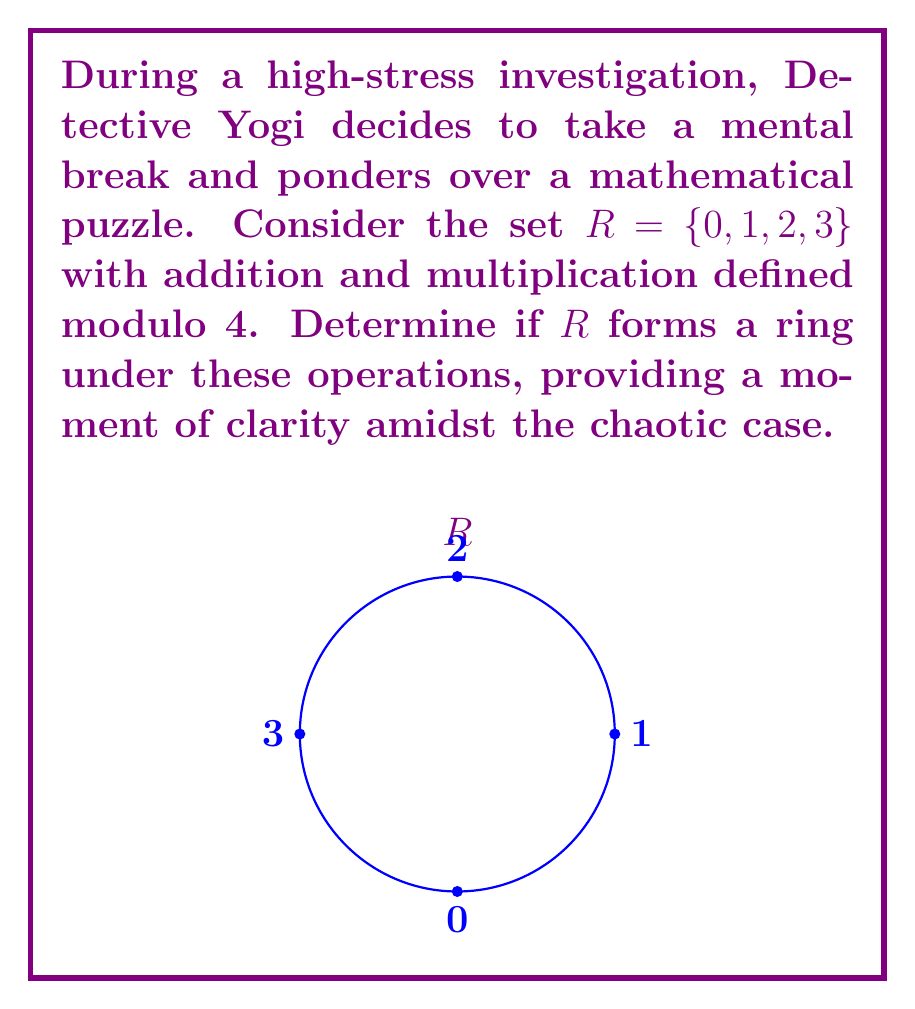Could you help me with this problem? To determine if $R$ forms a ring, we need to check if it satisfies the ring axioms:

1. $(R, +)$ is an abelian group:
   a) Closure: For all $a,b \in R$, $a + b \in R$ (mod 4)
   b) Associativity: $(a + b) + c = a + (b + c)$ for all $a,b,c \in R$
   c) Commutativity: $a + b = b + a$ for all $a,b \in R$
   d) Identity: $0$ is the additive identity
   e) Inverse: Each element has an additive inverse

2. $(R, \cdot)$ is a monoid:
   a) Closure: For all $a,b \in R$, $a \cdot b \in R$ (mod 4)
   b) Associativity: $(a \cdot b) \cdot c = a \cdot (b \cdot c)$ for all $a,b,c \in R$
   c) Identity: $1$ is the multiplicative identity

3. Distributive laws:
   a) $a \cdot (b + c) = (a \cdot b) + (a \cdot c)$ for all $a,b,c \in R$
   b) $(b + c) \cdot a = (b \cdot a) + (c \cdot a)$ for all $a,b,c \in R$

Let's verify each condition:

1. $(R, +)$ is an abelian group:
   a) Closure: $0+0=0$, $0+1=1$, $0+2=2$, $0+3=3$, $1+1=2$, $1+2=3$, $1+3=0$, $2+2=0$, $2+3=1$, $3+3=2$ (all in $R$)
   b) Associativity: Holds for modular addition
   c) Commutativity: Holds for modular addition
   d) Identity: $0$ is the additive identity
   e) Inverse: $0+0=0$, $1+3=0$, $2+2=0$, $3+1=0$

2. $(R, \cdot)$ is a monoid:
   a) Closure: $0\cdot0=0$, $0\cdot1=0$, $0\cdot2=0$, $0\cdot3=0$, $1\cdot1=1$, $1\cdot2=2$, $1\cdot3=3$, $2\cdot2=0$, $2\cdot3=2$, $3\cdot3=1$ (all in $R$)
   b) Associativity: Holds for modular multiplication
   c) Identity: $1$ is the multiplicative identity

3. Distributive laws:
   Both left and right distributivity hold for modular arithmetic

Since all conditions are satisfied, $R$ forms a ring under addition and multiplication modulo 4.
Answer: Yes, $R$ forms a ring. 